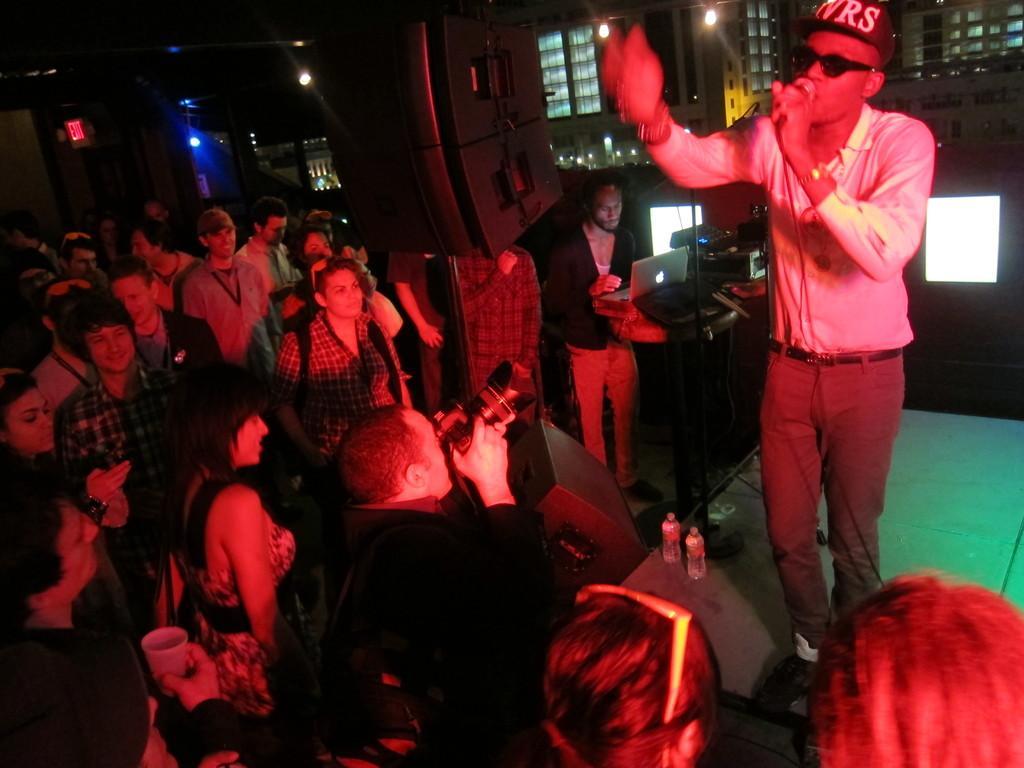Describe this image in one or two sentences. In this image a person is standing on the stage. He is holding a mike in his hand. He is wearing goggles and cap. Before him there is a person holding camera and he is carrying a bag. A person is standing near the table having a laptop and few objects on it. Beside him there is a sound speaker attached to the stand. Few persons are standing on the floor. A person is holding a glass. Background there are few buildings. 